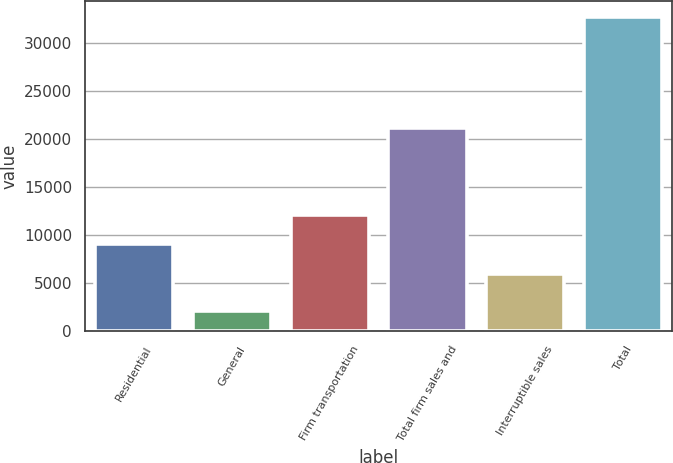Convert chart to OTSL. <chart><loc_0><loc_0><loc_500><loc_500><bar_chart><fcel>Residential<fcel>General<fcel>Firm transportation<fcel>Total firm sales and<fcel>Interruptible sales<fcel>Total<nl><fcel>9042.5<fcel>2066<fcel>12102<fcel>21082<fcel>5983<fcel>32661<nl></chart> 